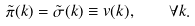<formula> <loc_0><loc_0><loc_500><loc_500>\tilde { \pi } ( k ) = \tilde { \sigma } ( k ) \equiv v ( k ) , \quad \forall k .</formula> 